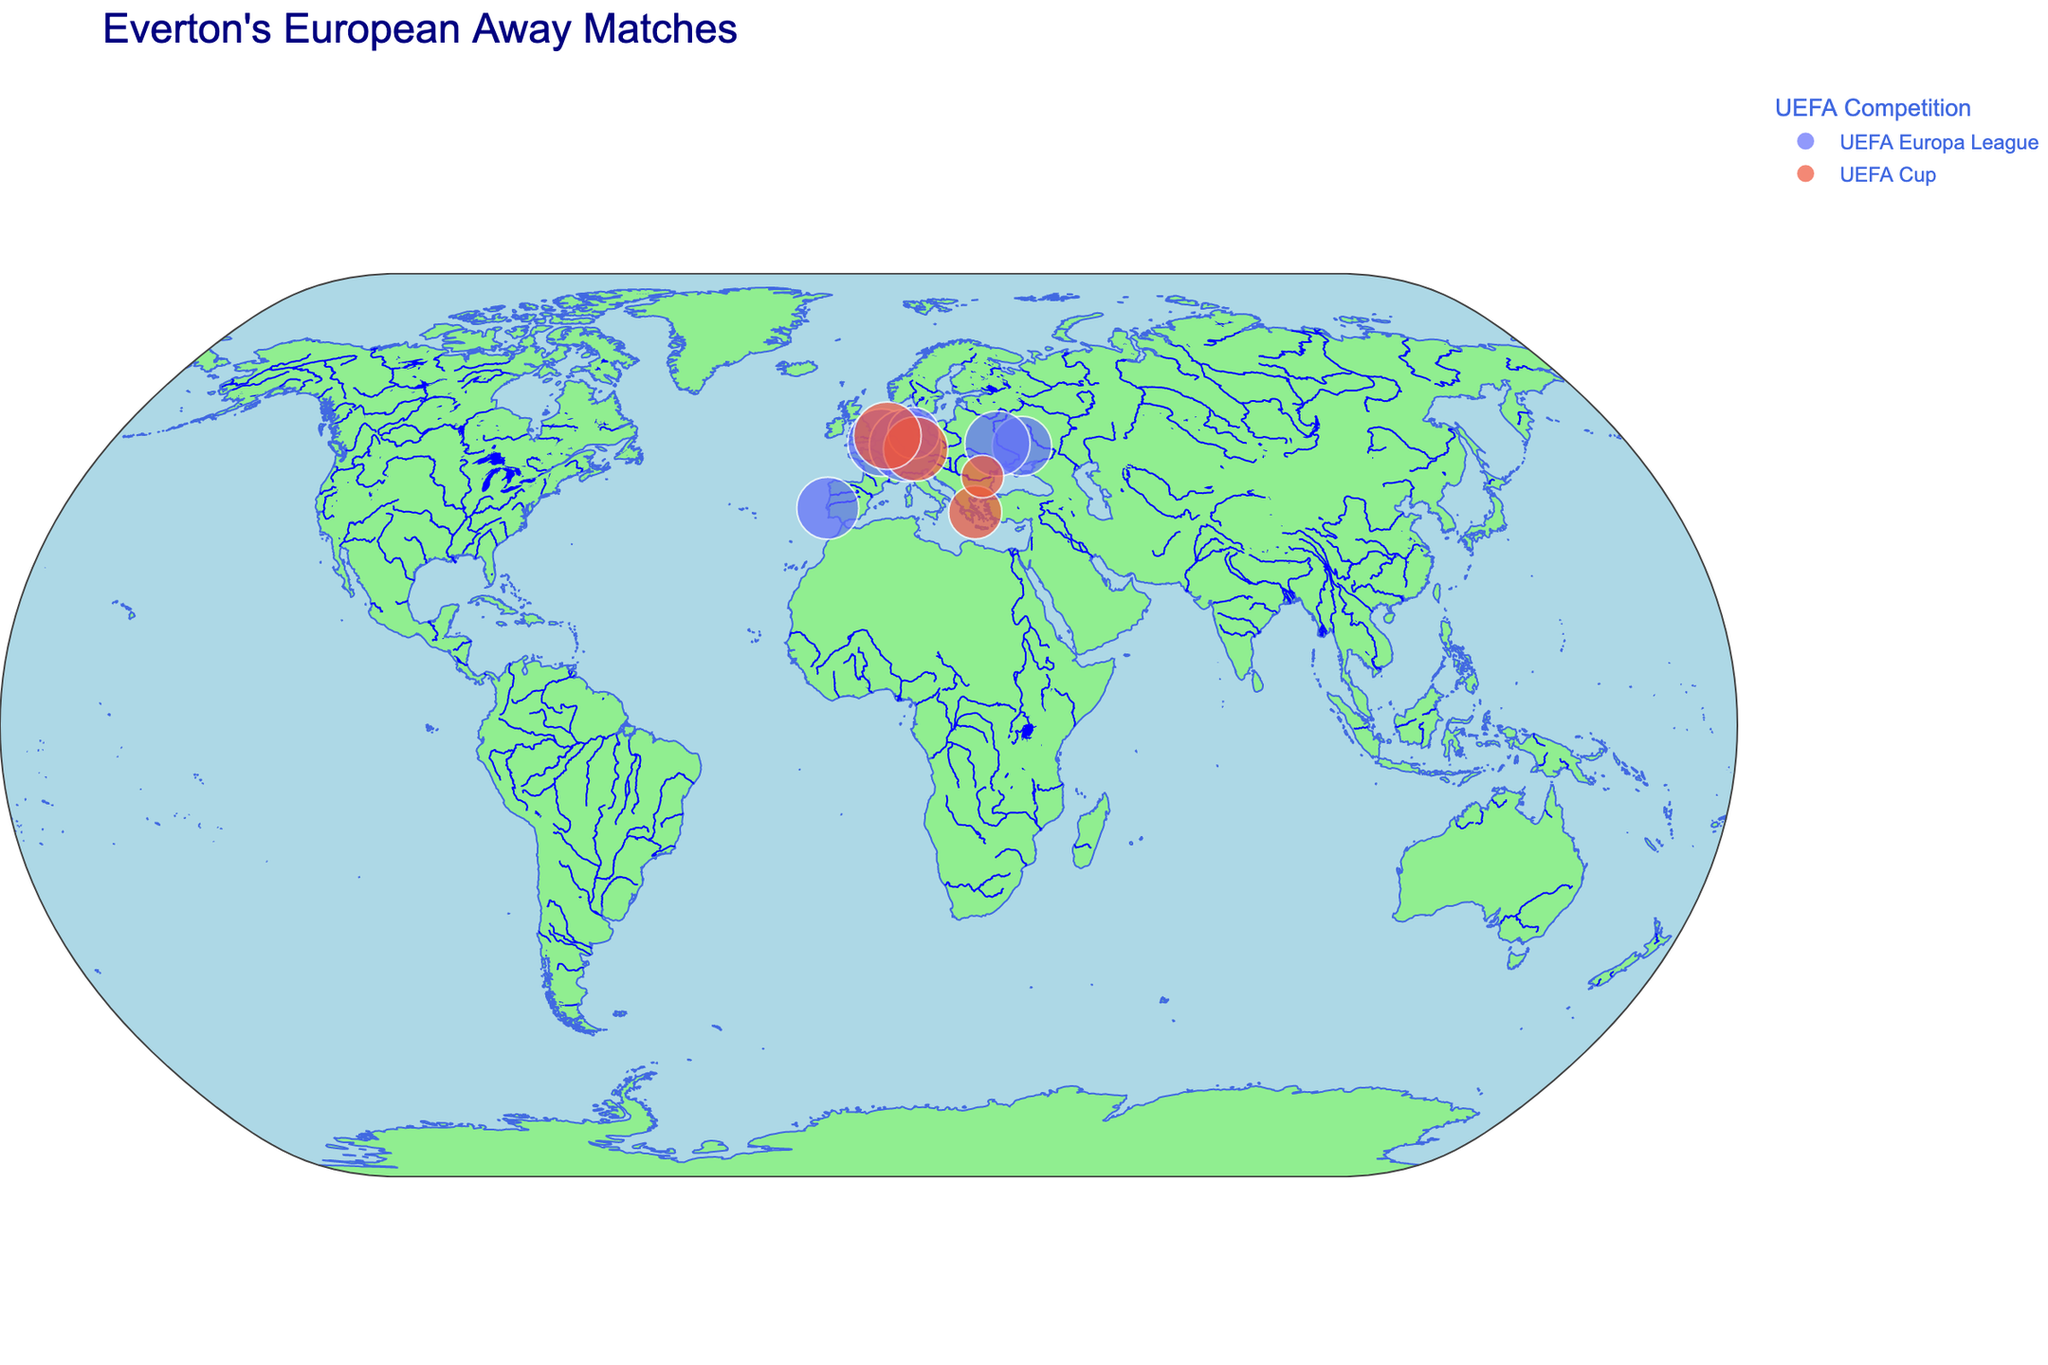How many matches did Everton play in Germany? The plot shows location markers on the map indicating the cities where matches were played and the corresponding attendance figures. By observing the markers, we can count three cities in Germany: Frankfurt, Nuremberg, and Wolfsburg.
Answer: 3 Which city had the highest attendance? By hovering over the markers on the plot, we can see the attendance figures for each city. Frankfurt in Germany had the highest attendance with 51,500.
Answer: Frankfurt Which competition has more data points, UEFA Cup or UEFA Europa League? By looking at the colors representing different competitions on the plot, we can count the number of markers for each. UEFA Europa League has 6 data points, while UEFA Cup has 4.
Answer: UEFA Europa League What's the total attendance for all matches in France and Ukraine combined? Hover over the markers to get attendance figures for Lille (France: 45,000), and Kharkiv (Ukraine: 35,000) and Kyiv (Ukraine: 42,000). Sum the values (45,000 + 35,000 + 42,000).
Answer: 122,000 Compare the attendance for the matches played in Portugal and Greece. Which country had a higher attendance? Hover over the markers to get the attendance figures for Lisbon in Portugal (38,000) and Athens in Greece (28,000). Compare the numbers; Lisbon in Portugal had a higher attendance.
Answer: Portugal Which year did Everton play in Bucharest? Hovering over the marker in Bucharest reveals the match details, showing that the game took place in 2005.
Answer: 2005 What is the geographical spread of Everton's European away matches? By looking at the map, we see markers spread across Western, Central, and Eastern Europe, including cities in France, Germany, Portugal, Greece, Netherlands, Romania, Ukraine.
Answer: Western to Eastern Europe Which city had the lowest recorded attendance and what was it? By examining the attendance figures through hovering over markers, we find Bucharest had the lowest attendance at 18,000.
Answer: Bucharest, 18,000 Determine the average attendance for matches in Germany. Hover over the markers for the German cities (Frankfurt: 51,500, Nuremberg: 41,000, Wolfsburg: 26,000). Sum these values and divide by the number of cities (3). (51,500 + 41,000 + 26,000) / 3 = 39,500.
Answer: 39,500 In which country did Everton play in both 2014 and 2015? By hovering over relevant markers, observe that Everton played in Ukraine in both 2014 (Kharkiv) and 2015 (Kyiv).
Answer: Ukraine 